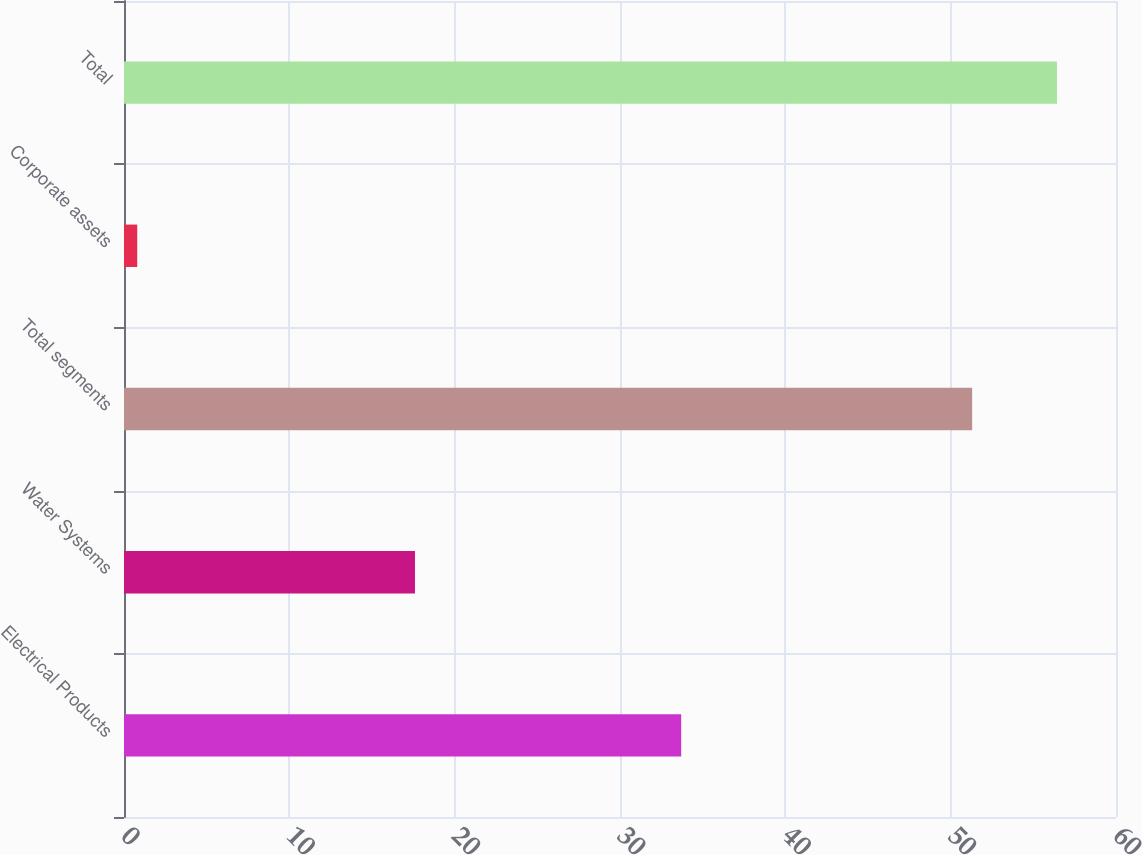<chart> <loc_0><loc_0><loc_500><loc_500><bar_chart><fcel>Electrical Products<fcel>Water Systems<fcel>Total segments<fcel>Corporate assets<fcel>Total<nl><fcel>33.7<fcel>17.6<fcel>51.3<fcel>0.8<fcel>56.43<nl></chart> 